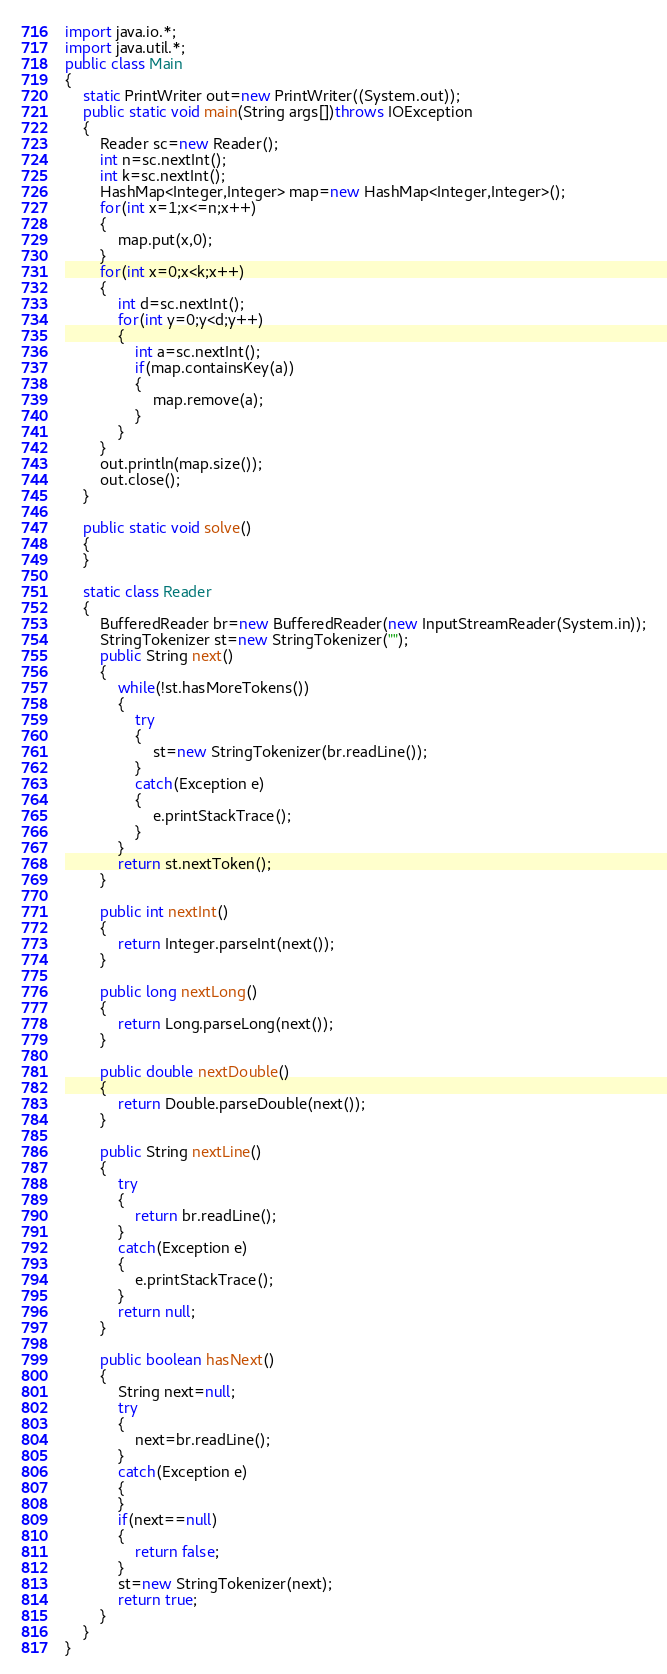Convert code to text. <code><loc_0><loc_0><loc_500><loc_500><_Java_>import java.io.*;
import java.util.*;
public class Main
{
    static PrintWriter out=new PrintWriter((System.out));
    public static void main(String args[])throws IOException
    {
        Reader sc=new Reader();
        int n=sc.nextInt();
        int k=sc.nextInt();
        HashMap<Integer,Integer> map=new HashMap<Integer,Integer>();
        for(int x=1;x<=n;x++)
        {
            map.put(x,0);
        }
        for(int x=0;x<k;x++)
        {
            int d=sc.nextInt();
            for(int y=0;y<d;y++)
            {
                int a=sc.nextInt();
                if(map.containsKey(a))
                {
                    map.remove(a);
                }
            }
        }
        out.println(map.size());
        out.close();
    }

    public static void solve()
    {
    }

    static class Reader 
    { 
        BufferedReader br=new BufferedReader(new InputStreamReader(System.in));
        StringTokenizer st=new StringTokenizer("");
        public String next()
        {
            while(!st.hasMoreTokens())
            {
                try
                {
                    st=new StringTokenizer(br.readLine());
                }
                catch(Exception e)
                {
                    e.printStackTrace();
                }
            }
            return st.nextToken();
        }

        public int nextInt()
        {
            return Integer.parseInt(next());
        }

        public long nextLong()
        {
            return Long.parseLong(next());
        }

        public double nextDouble()
        {
            return Double.parseDouble(next());
        }

        public String nextLine()
        {
            try
            {
                return br.readLine();
            }
            catch(Exception e)
            {
                e.printStackTrace();
            }
            return null;
        }

        public boolean hasNext()
        {
            String next=null;
            try
            {
                next=br.readLine();
            }
            catch(Exception e)
            {
            }
            if(next==null)
            {
                return false;
            }
            st=new StringTokenizer(next);
            return true;
        }
    } 
}</code> 